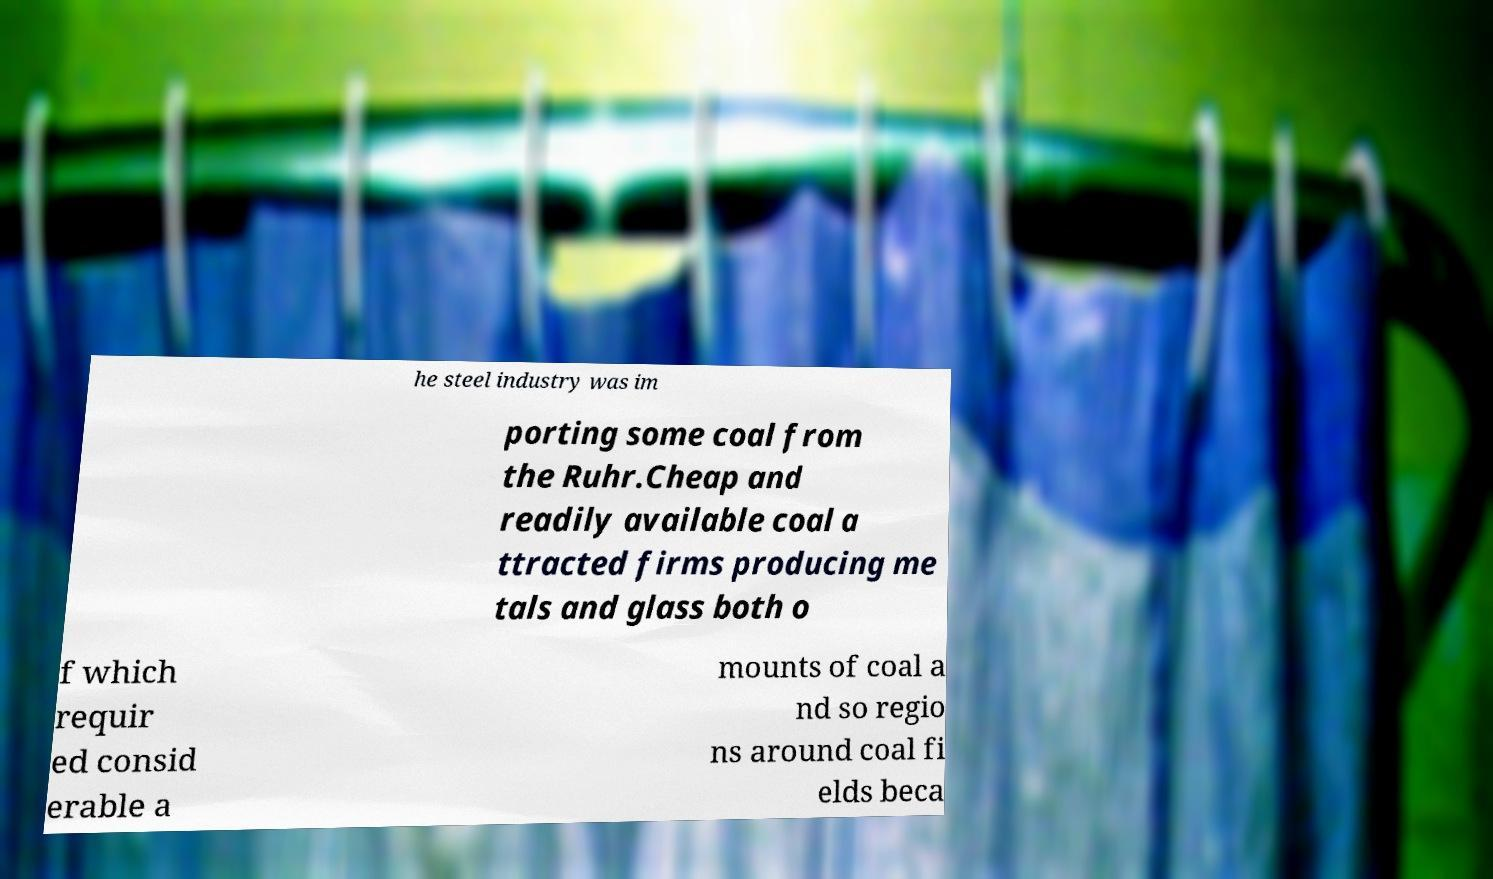Could you extract and type out the text from this image? he steel industry was im porting some coal from the Ruhr.Cheap and readily available coal a ttracted firms producing me tals and glass both o f which requir ed consid erable a mounts of coal a nd so regio ns around coal fi elds beca 